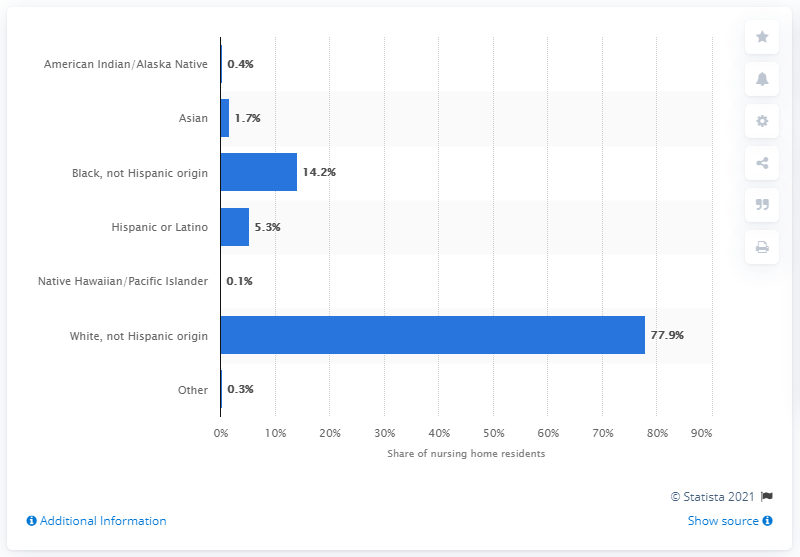Give some essential details in this illustration. In 2014, approximately 5.3% of nursing home residents identified as Hispanic or Latino, according to data. In 2014, approximately 5.3% of nursing home residents were Hispanic or Latino, according to data. 